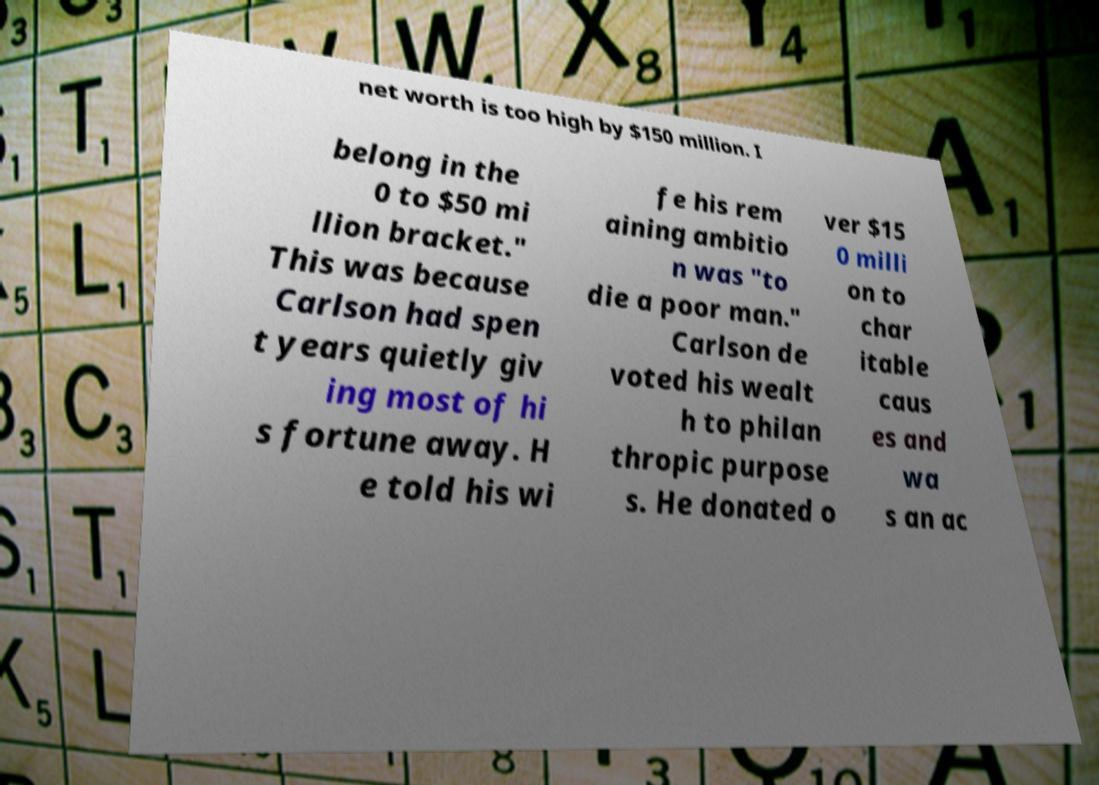Can you accurately transcribe the text from the provided image for me? net worth is too high by $150 million. I belong in the 0 to $50 mi llion bracket." This was because Carlson had spen t years quietly giv ing most of hi s fortune away. H e told his wi fe his rem aining ambitio n was "to die a poor man." Carlson de voted his wealt h to philan thropic purpose s. He donated o ver $15 0 milli on to char itable caus es and wa s an ac 